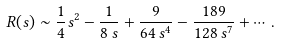Convert formula to latex. <formula><loc_0><loc_0><loc_500><loc_500>R ( s ) \sim { \frac { 1 } { 4 } } s ^ { 2 } - { \frac { 1 } { 8 \, s } } + { \frac { 9 } { 6 4 \, s ^ { 4 } } } - { \frac { 1 8 9 } { 1 2 8 \, s ^ { 7 } } } + \cdots \, .</formula> 